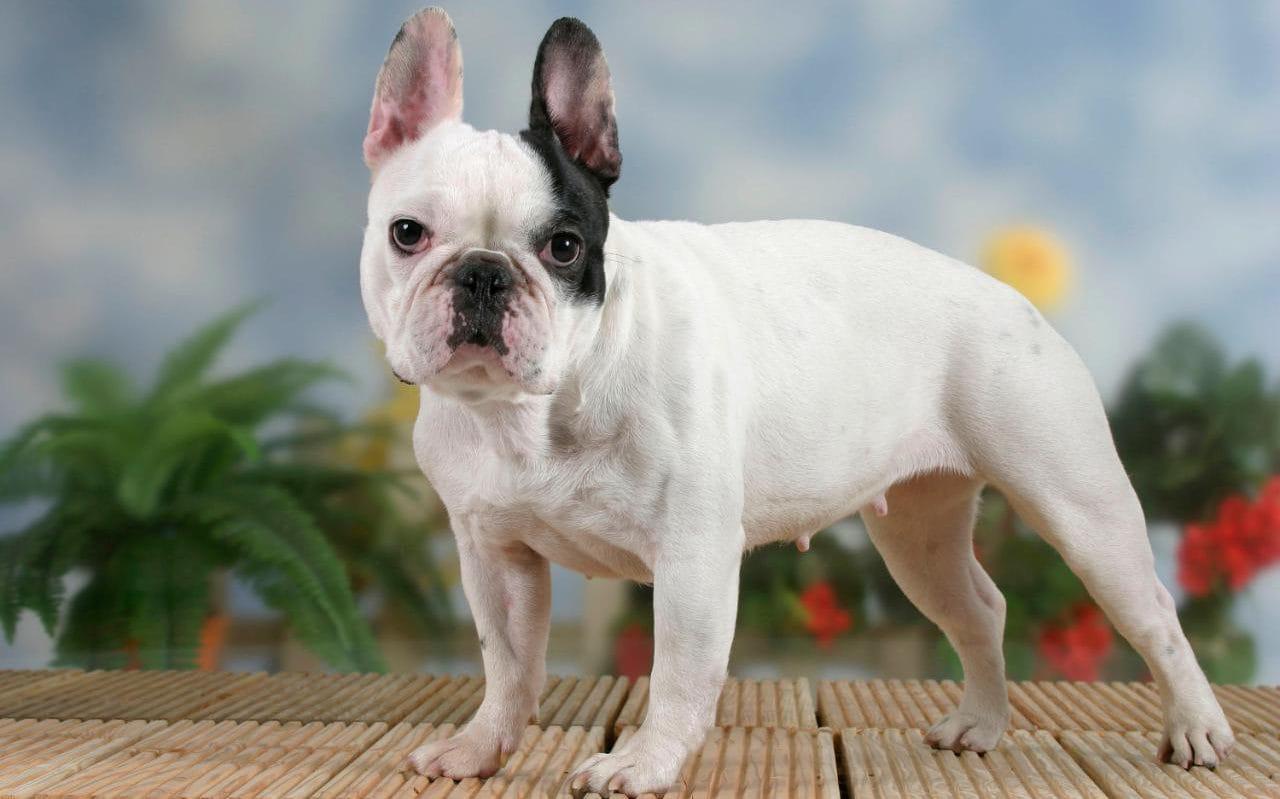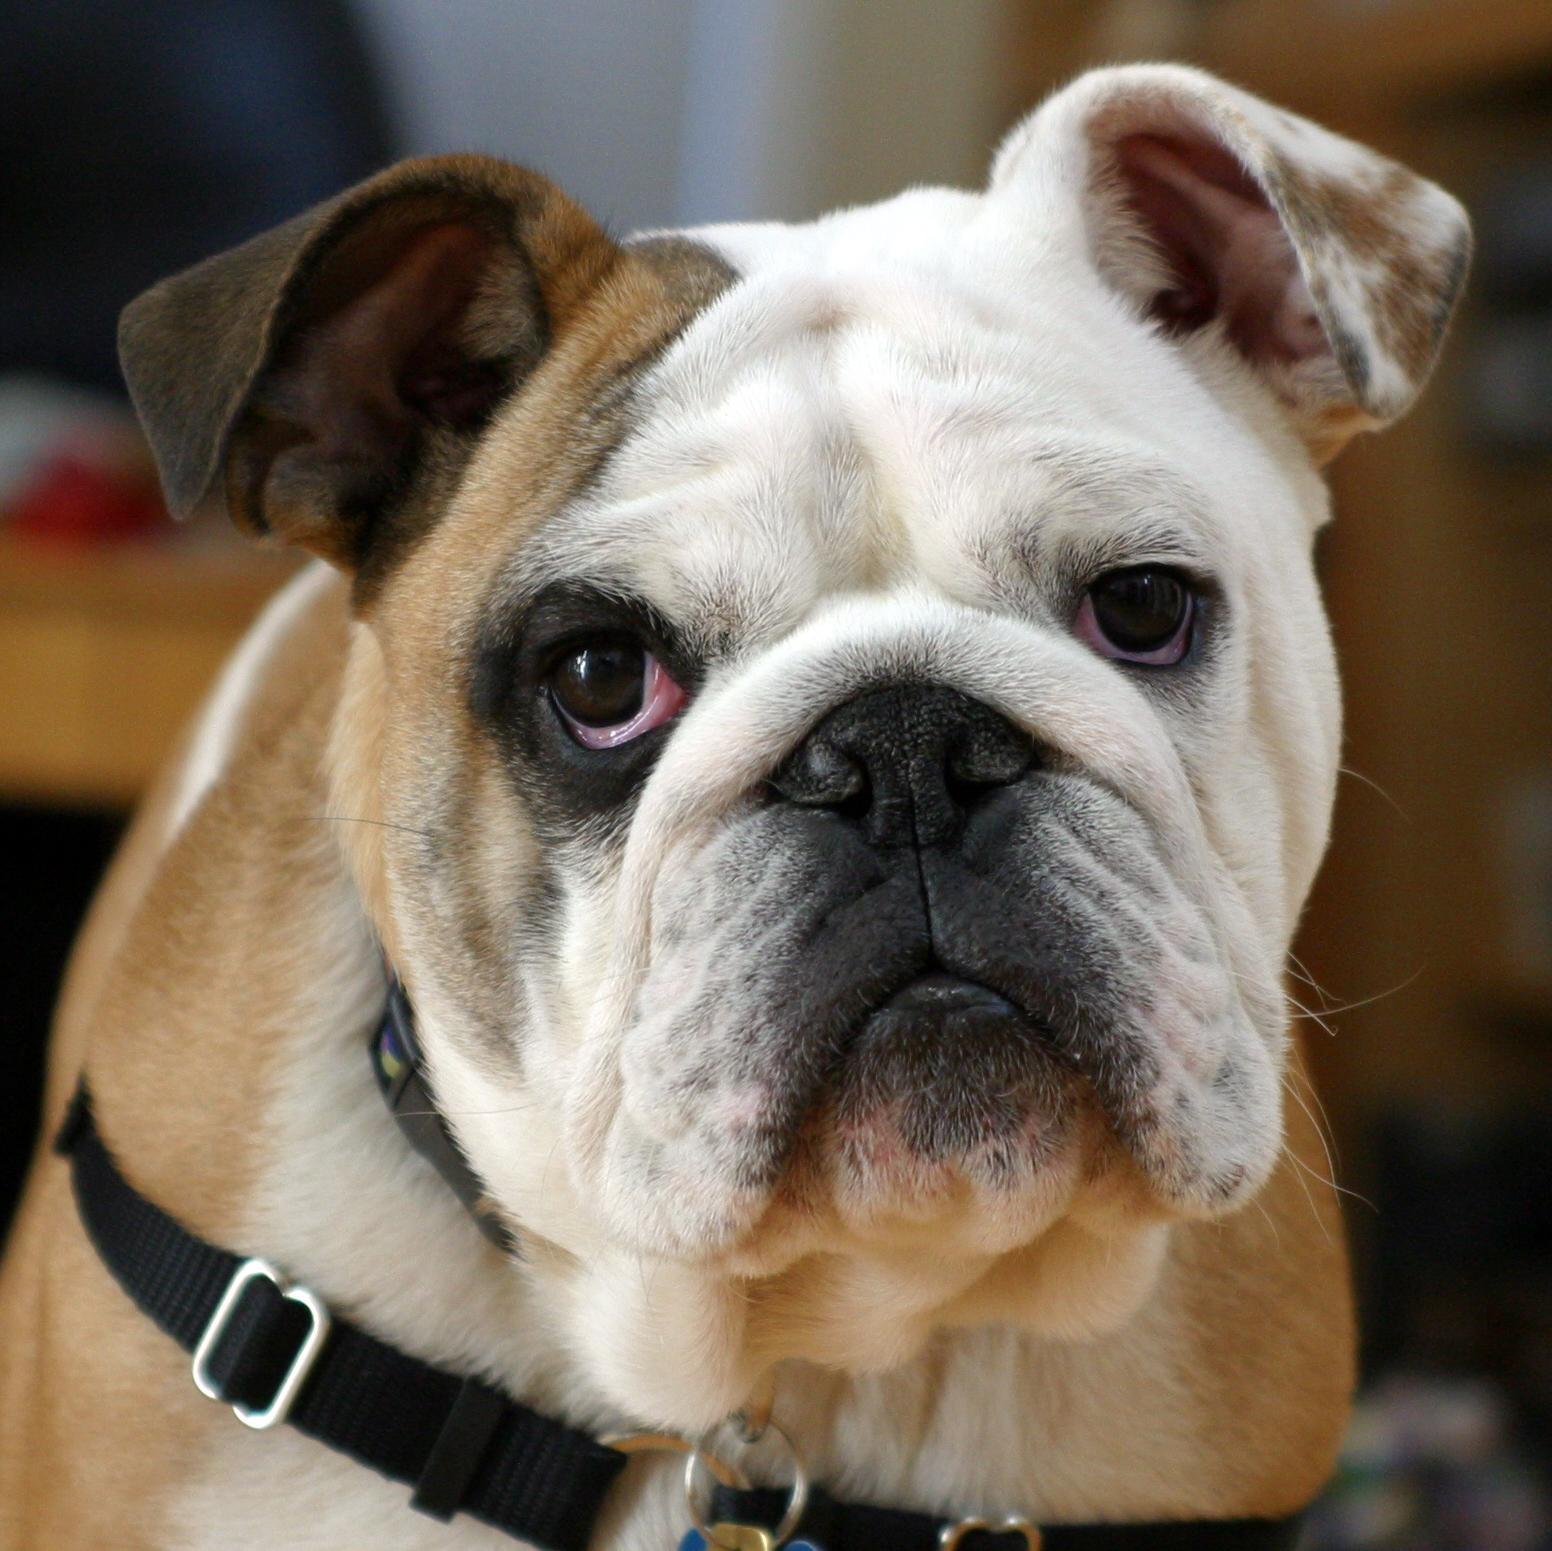The first image is the image on the left, the second image is the image on the right. Analyze the images presented: Is the assertion "There are two french bulldogs, and zero english bulldogs." valid? Answer yes or no. No. The first image is the image on the left, the second image is the image on the right. Given the left and right images, does the statement "There is at least one dog standing on grass-covered ground." hold true? Answer yes or no. No. 